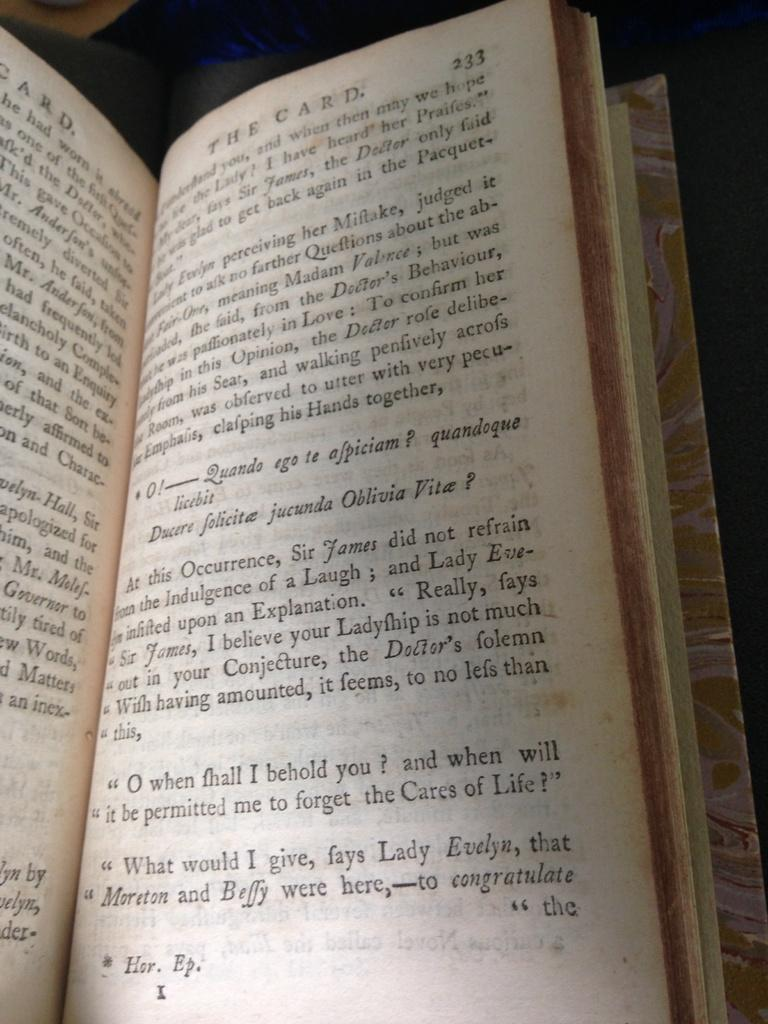<image>
Describe the image concisely. A book called The Card is open to page 233. 